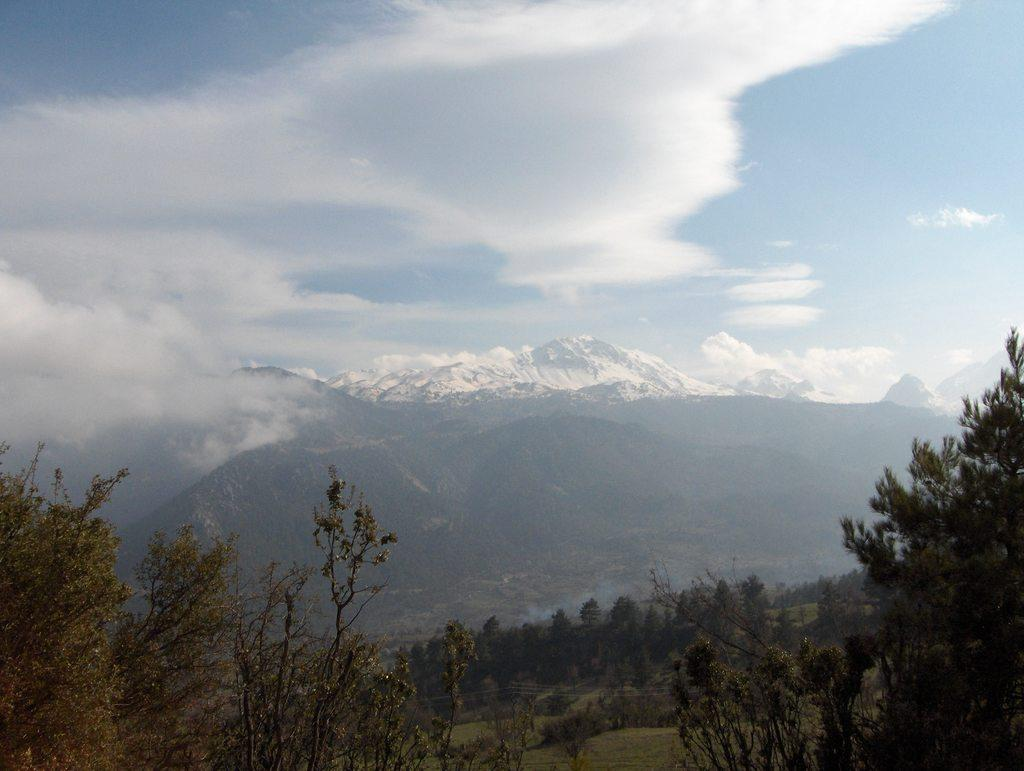What is located in the center of the image? There are trees and mountains in the center of the image. What is the condition of the mountains in the center of the image? The mountains in the center of the image are not snow-covered. What can be seen in the background of the image? There are snow-covered mountains and clouds in the background of the image. What is visible in the sky in the background of the image? The sky is visible in the background of the image. What type of juice is being served in the image? There is no juice present in the image; it features trees, mountains, and a sky. What is your opinion on the metal content in the image? There is no metal content in the image, as it primarily consists of natural elements like trees, mountains, and sky. 